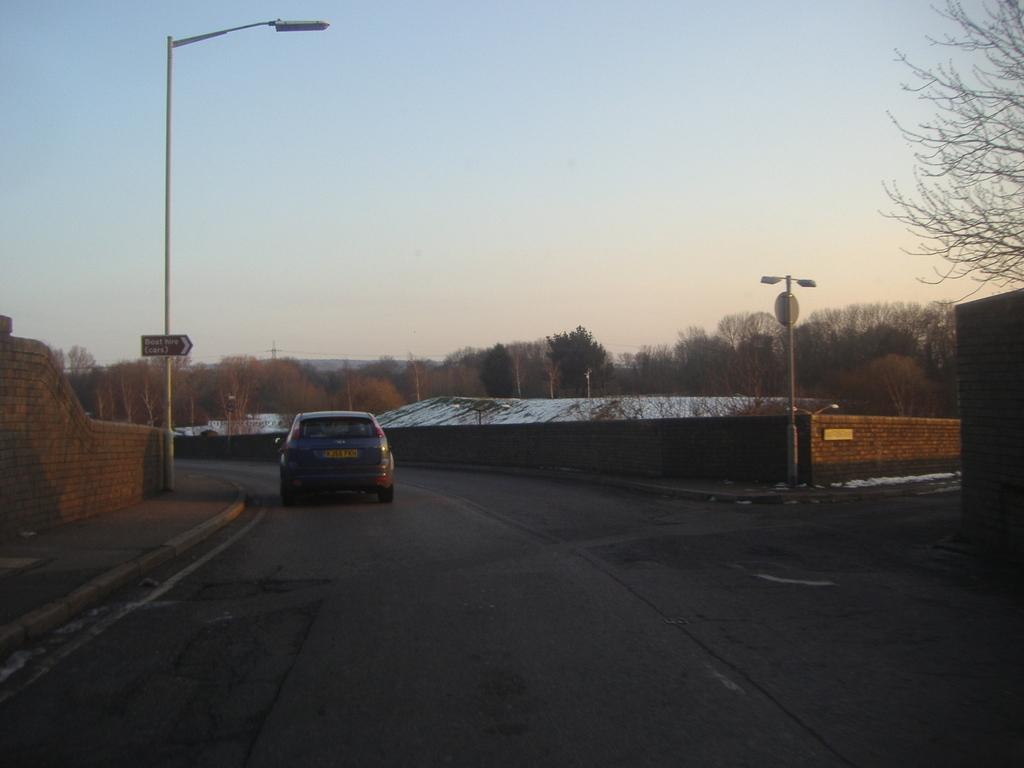What is parked on the ground in the image? There is a car parked on the ground in the image. What can be seen in the background of the image? There is a group of poles, trees, a building with a roof, and the sky visible in the background of the image. Where is the tent set up for lunch in the image? There is no tent or lunch set up in the image; it only features a car parked on the ground and various background elements. 